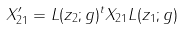<formula> <loc_0><loc_0><loc_500><loc_500>X _ { 2 1 } ^ { \prime } = L ( z _ { 2 } ; g ) ^ { t } X _ { 2 1 } L ( z _ { 1 } ; g )</formula> 